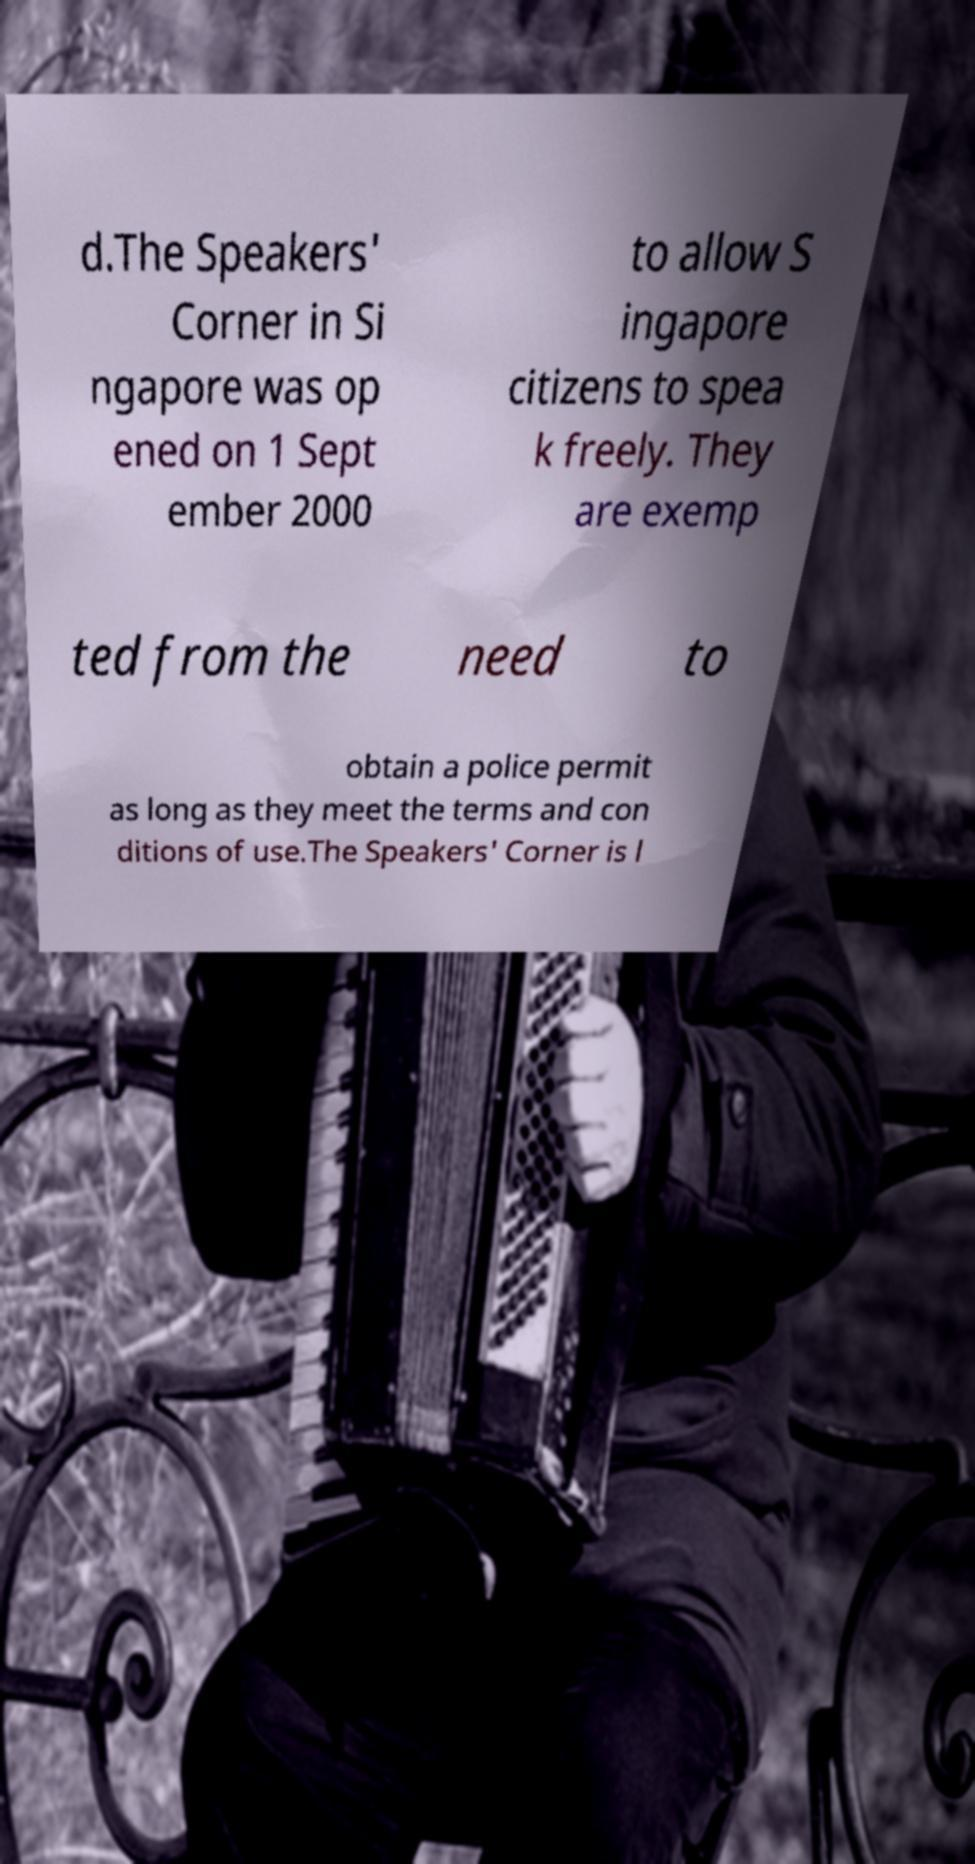For documentation purposes, I need the text within this image transcribed. Could you provide that? d.The Speakers' Corner in Si ngapore was op ened on 1 Sept ember 2000 to allow S ingapore citizens to spea k freely. They are exemp ted from the need to obtain a police permit as long as they meet the terms and con ditions of use.The Speakers' Corner is l 